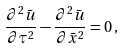<formula> <loc_0><loc_0><loc_500><loc_500>\frac { \partial ^ { 2 } \bar { u } } { \partial \tau ^ { 2 } } - \frac { \partial ^ { 2 } \bar { u } } { \partial \bar { x } ^ { 2 } } = 0 \, ,</formula> 